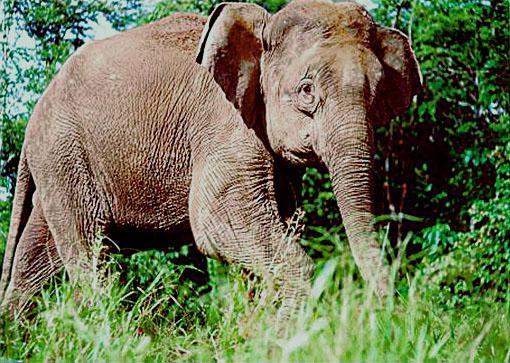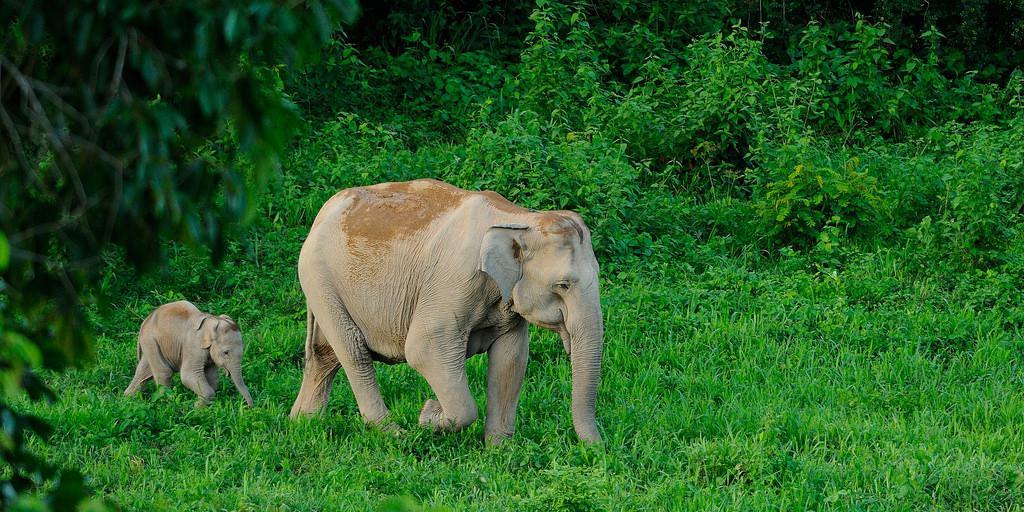The first image is the image on the left, the second image is the image on the right. Examine the images to the left and right. Is the description "The left image contains a baby elephant with an adult" accurate? Answer yes or no. No. The first image is the image on the left, the second image is the image on the right. Analyze the images presented: Is the assertion "In the right image the elephant has tusks" valid? Answer yes or no. No. 